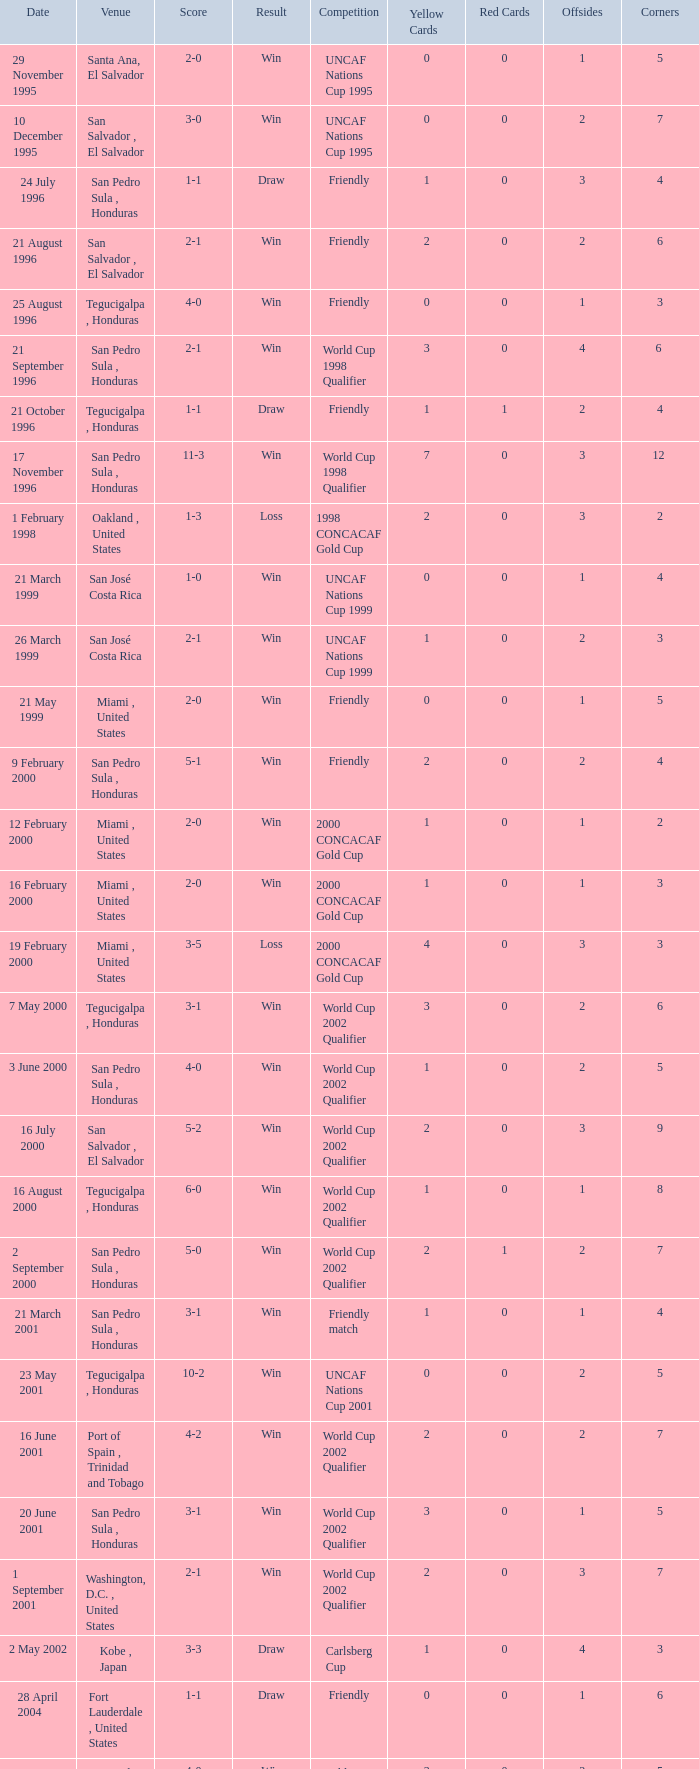What is the venue for the friendly competition and score of 4-0? Tegucigalpa , Honduras. 